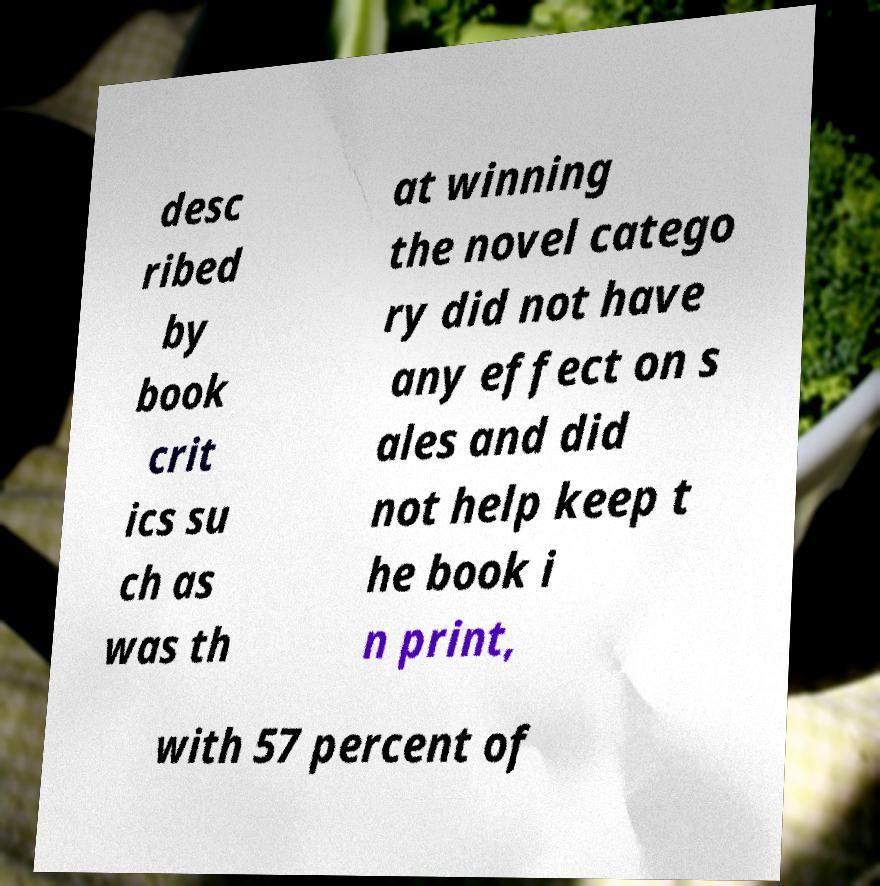Please identify and transcribe the text found in this image. desc ribed by book crit ics su ch as was th at winning the novel catego ry did not have any effect on s ales and did not help keep t he book i n print, with 57 percent of 